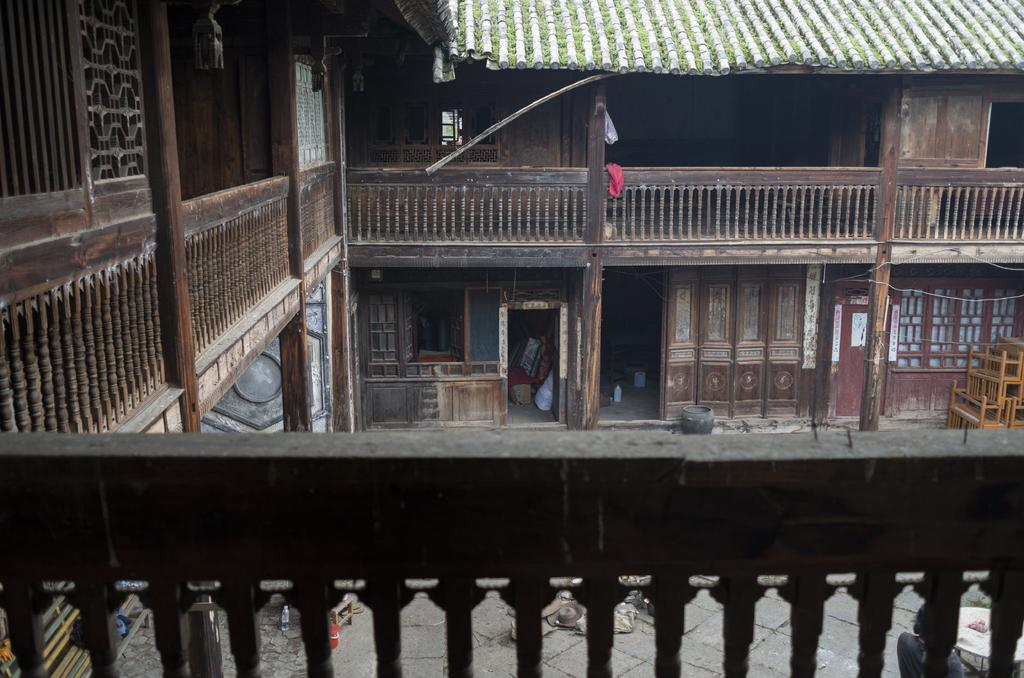What type of structure is visible in the image? There is a building in the image. What object can be seen near the building? There is a bottle in the image. What type of seating is available in the image? There are benches in the image. What is used for waste disposal in the image? There is a bin in the image. What type of personal items are visible in the image? There are clothes in the image. What type of attraction is visible in the image? There is no attraction present in the image; it only features a building, bottle, benches, bin, and clothes. What type of locket can be seen hanging from the clothes in the image? There is no locket visible in the image; only clothes are present. 